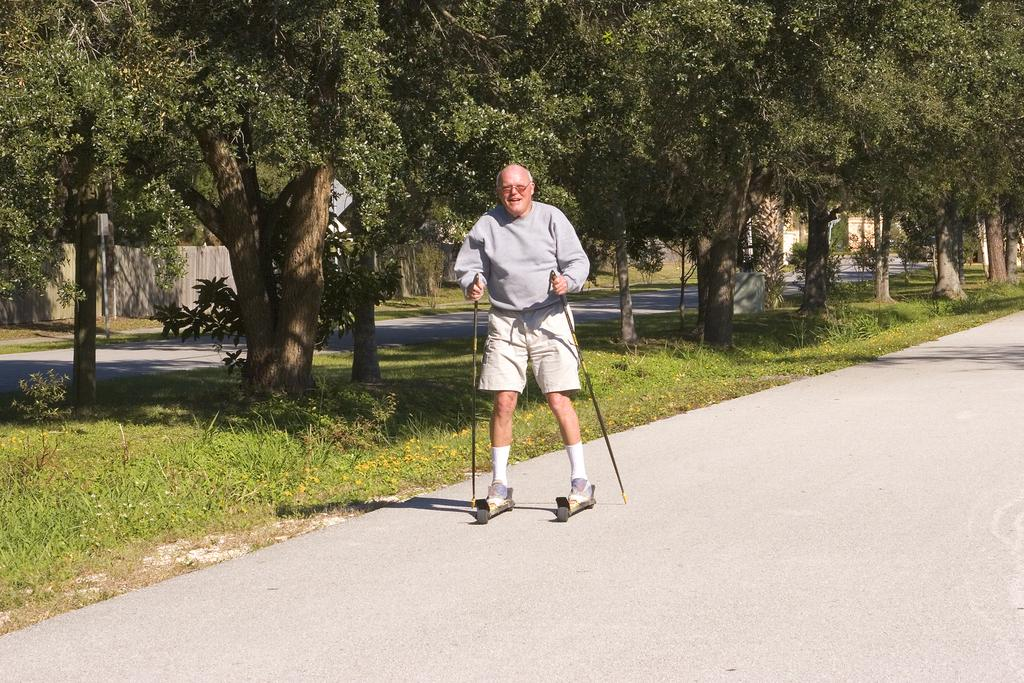What is the man in the image doing? The man is standing in the image and holding stocks. What can be seen in the background of the image? There are trees visible in the image. What type of pathway is present in the image? There is a road in the image. Can you see the man's brother in the image? There is no mention of a brother in the image, so it cannot be determined if the man has a brother present. 